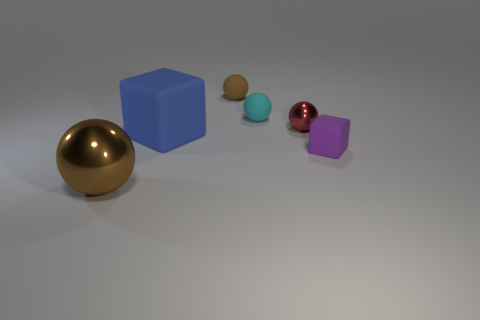Subtract all large brown shiny spheres. How many spheres are left? 3 Subtract 3 balls. How many balls are left? 1 Add 3 small purple cubes. How many objects exist? 9 Subtract all blue cubes. How many cubes are left? 1 Subtract all cubes. How many objects are left? 4 Add 4 tiny metallic objects. How many tiny metallic objects exist? 5 Subtract 0 gray blocks. How many objects are left? 6 Subtract all green blocks. Subtract all cyan spheres. How many blocks are left? 2 Subtract all purple cylinders. How many blue blocks are left? 1 Subtract all large rubber cylinders. Subtract all tiny red things. How many objects are left? 5 